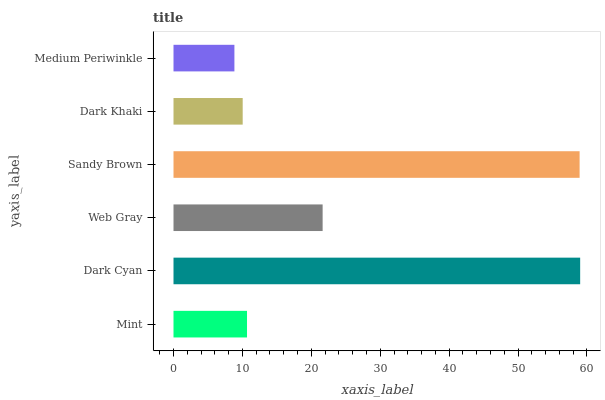Is Medium Periwinkle the minimum?
Answer yes or no. Yes. Is Dark Cyan the maximum?
Answer yes or no. Yes. Is Web Gray the minimum?
Answer yes or no. No. Is Web Gray the maximum?
Answer yes or no. No. Is Dark Cyan greater than Web Gray?
Answer yes or no. Yes. Is Web Gray less than Dark Cyan?
Answer yes or no. Yes. Is Web Gray greater than Dark Cyan?
Answer yes or no. No. Is Dark Cyan less than Web Gray?
Answer yes or no. No. Is Web Gray the high median?
Answer yes or no. Yes. Is Mint the low median?
Answer yes or no. Yes. Is Sandy Brown the high median?
Answer yes or no. No. Is Dark Khaki the low median?
Answer yes or no. No. 